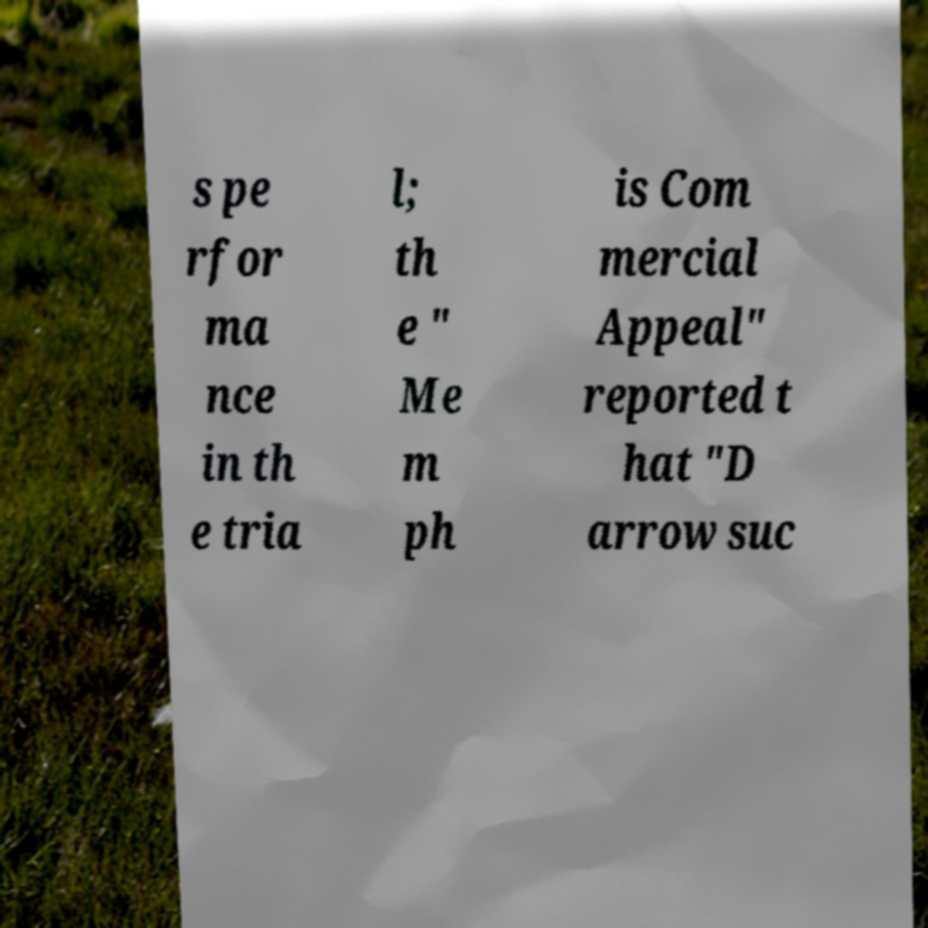Can you accurately transcribe the text from the provided image for me? s pe rfor ma nce in th e tria l; th e " Me m ph is Com mercial Appeal" reported t hat "D arrow suc 